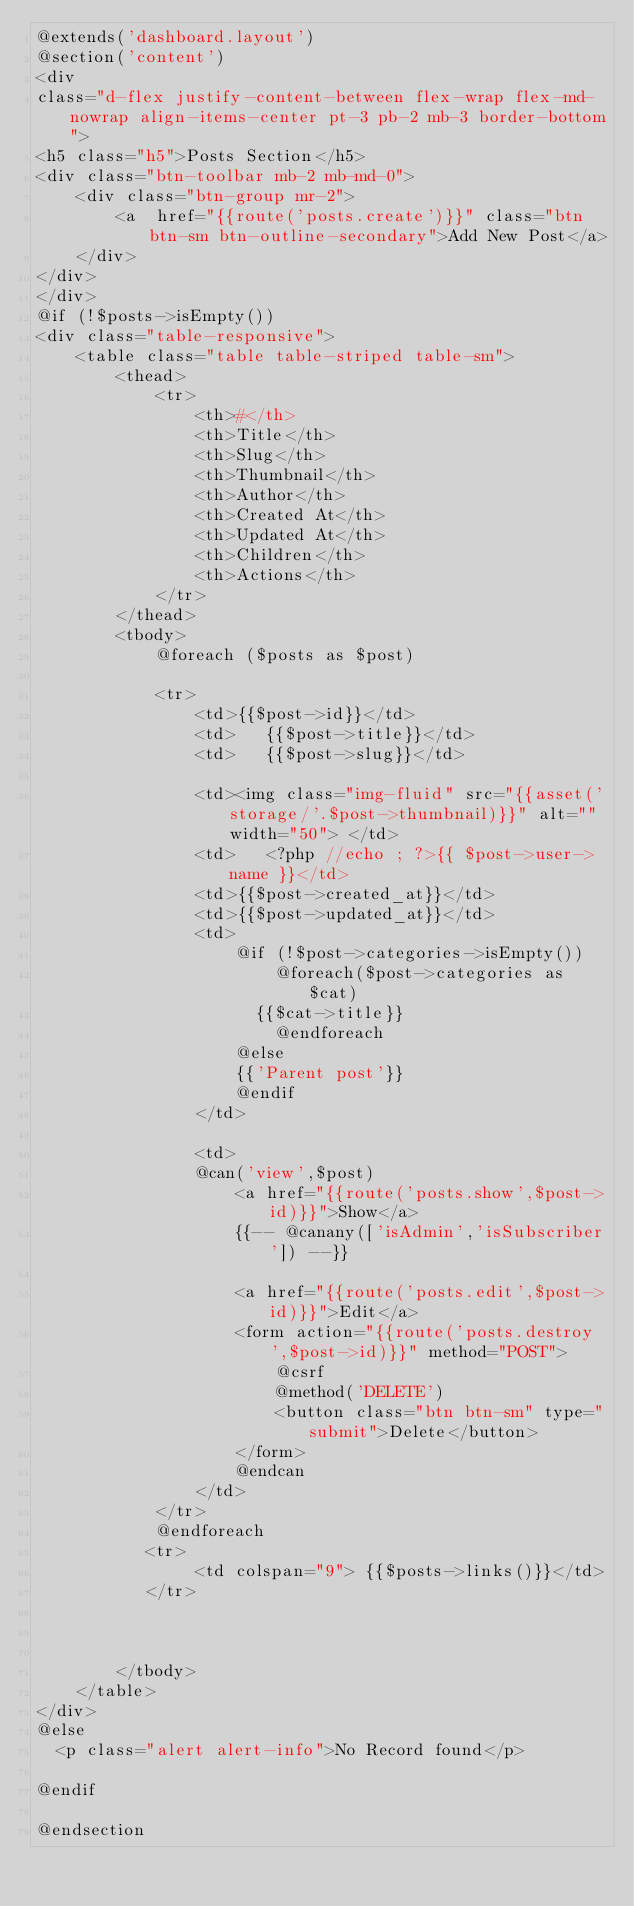Convert code to text. <code><loc_0><loc_0><loc_500><loc_500><_PHP_>@extends('dashboard.layout')
@section('content')
<div
class="d-flex justify-content-between flex-wrap flex-md-nowrap align-items-center pt-3 pb-2 mb-3 border-bottom">
<h5 class="h5">Posts Section</h5>
<div class="btn-toolbar mb-2 mb-md-0">
    <div class="btn-group mr-2">
        <a  href="{{route('posts.create')}}" class="btn btn-sm btn-outline-secondary">Add New Post</a>
    </div>
</div>
</div>
@if (!$posts->isEmpty())
<div class="table-responsive">
    <table class="table table-striped table-sm">
        <thead>
            <tr>
                <th>#</th>
                <th>Title</th>
                <th>Slug</th>
                <th>Thumbnail</th>
                <th>Author</th>
                <th>Created At</th>
                <th>Updated At</th>
                <th>Children</th>
                <th>Actions</th>
            </tr>
        </thead>
        <tbody>
            @foreach ($posts as $post)
         
            <tr>
                <td>{{$post->id}}</td>
                <td>   {{$post->title}}</td>
                <td>   {{$post->slug}}</td>
              
                <td><img class="img-fluid" src="{{asset('storage/'.$post->thumbnail)}}" alt="" width="50"> </td>
                <td>   <?php //echo ; ?>{{ $post->user->name }}</td>
                <td>{{$post->created_at}}</td>
                <td>{{$post->updated_at}}</td>
                <td>
                    @if (!$post->categories->isEmpty())
                        @foreach($post->categories as $cat)
                      {{$cat->title}}
                        @endforeach
                    @else
                    {{'Parent post'}}
                    @endif
                </td>
               
                <td>
                @can('view',$post)
                    <a href="{{route('posts.show',$post->id)}}">Show</a>
                    {{-- @canany(['isAdmin','isSubscriber']) --}}

                    <a href="{{route('posts.edit',$post->id)}}">Edit</a>
                    <form action="{{route('posts.destroy',$post->id)}}" method="POST">
                        @csrf
                        @method('DELETE')
                        <button class="btn btn-sm" type="submit">Delete</button>
                    </form>
                    @endcan
                </td>
            </tr>
            @endforeach
           <tr>
                <td colspan="9"> {{$posts->links()}}</td>
           </tr>
           
          
           
        </tbody>
    </table>
</div>    
@else
  <p class="alert alert-info">No Record found</p>    

@endif
    
@endsection</code> 